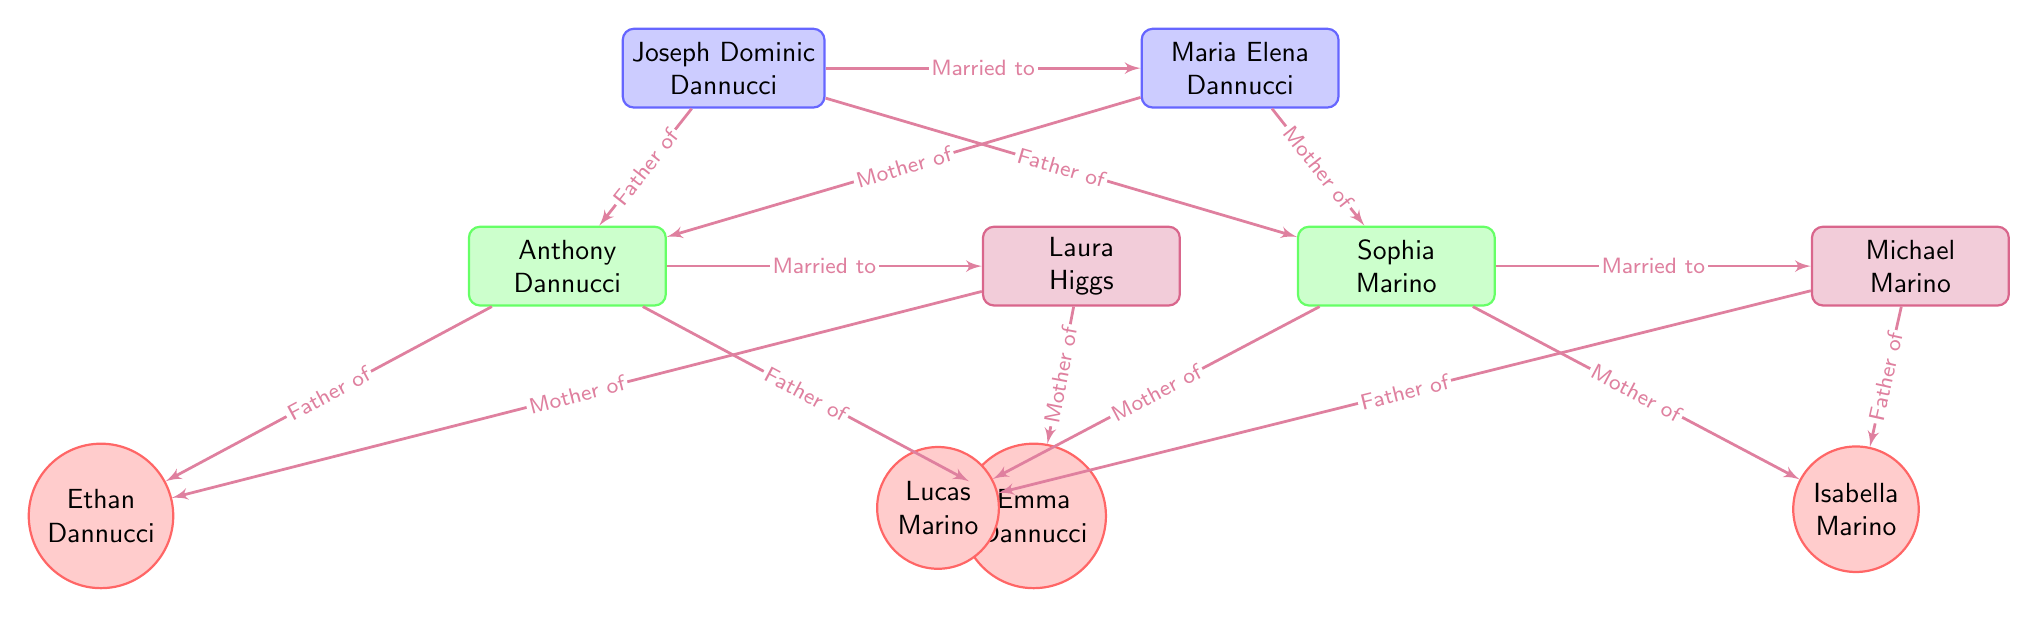What is the name of Joseph Dominic Dannucci's spouse? The diagram indicates that Joseph Dominic Dannucci is married to Maria Elena Dannucci, as shown by the direct connection labeled "Married to."
Answer: Maria Elena Dannucci How many children does Anthony Dannucci have? Anthony Dannucci is connected to two nodes labeled Ethan Dannucci and Emma Dannucci, indicating he is the father of both. Therefore, he has two children.
Answer: 2 Which grandchild belongs to Sophia Marino? Sophia Marino is connected to two nodes representing her children, Lucas Marino and Isabella Marino. Further, these children are connected to the grandchildren. Therefore, Lucas and Isabella are her grandchildren. The question specifically asks for a name, and Lucas Marino is one of them.
Answer: Lucas Marino How are Joseph Dominic Dannucci and Anthony Dannucci related? Joseph Dominic Dannucci is connected directly with a relationship labeled "Father of," which shows that he is the father of Anthony Dannucci.
Answer: Father How many members are in the third generation (grandchildren)? The diagram shows four grandchildren represented as circular nodes: Ethan Dannucci, Emma Dannucci, Lucas Marino, and Isabella Marino. Thus, the total count of grandchildren is four.
Answer: 4 What is the relationship between Laura Higgs and Ethan Dannucci? The diagram indicates that Ethan Dannucci is connected to Laura Higgs through a line labeled "Mother of," showing that she is his mother.
Answer: Mother What shapes represent the grandparents in this family tree? The grandparents in the family tree are represented by rectangles with rounded corners, colored blue. These shapes are assigned the style "grandparent" in the diagram.
Answer: Rectangle Who is the father of Lucas Marino? The relationship defined in the diagram indicates that Lucas Marino's father is Michael Marino, as indicated by the "Father of" connection.
Answer: Michael Marino 